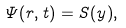Convert formula to latex. <formula><loc_0><loc_0><loc_500><loc_500>\Psi ( r , t ) = S ( y ) ,</formula> 